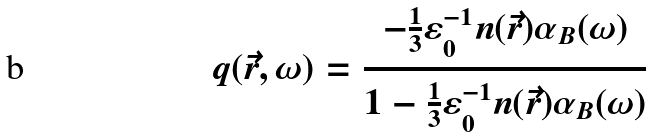Convert formula to latex. <formula><loc_0><loc_0><loc_500><loc_500>q ( \vec { r } , \omega ) = \frac { - \frac { 1 } { 3 } \varepsilon _ { 0 } ^ { - 1 } n ( \vec { r } ) \alpha _ { B } ( \omega ) } { 1 - \frac { 1 } { 3 } \varepsilon _ { 0 } ^ { - 1 } n ( \vec { r } ) \alpha _ { B } ( \omega ) }</formula> 